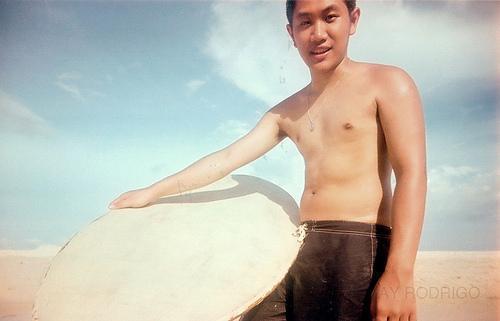How many people are in the scene?
Give a very brief answer. 1. 